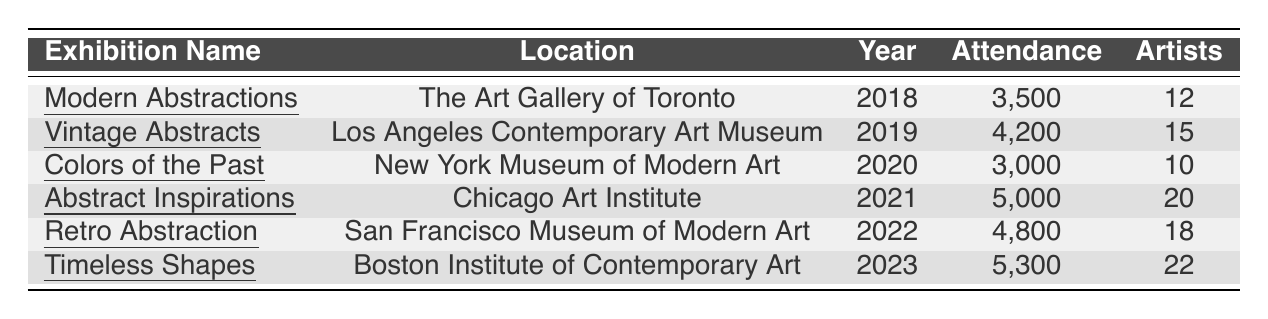What was the attendance for the exhibition "Abstract Inspirations"? The table specifies that the attendance for "Abstract Inspirations" in 2021 was 5,000.
Answer: 5,000 Which exhibition had the highest attendance? By comparing the attendance numbers, it can be seen that "Timeless Shapes" in 2023, with an attendance of 5,300, had the highest attendance.
Answer: 5,300 How many artists participated in "Retro Abstraction"? According to the table, 18 artists participated in the "Retro Abstraction" exhibition in 2022.
Answer: 18 What was the total attendance across all exhibitions from 2018 to 2023? Summing the attendance figures: 3,500 + 4,200 + 3,000 + 5,000 + 4,800 + 5,300 = 25,800.
Answer: 25,800 In which year did "Colors of the Past" take place? The table indicates that "Colors of the Past" was held in 2020.
Answer: 2020 Did the attendance increase from 2019 to 2022? The attendance figures show 4,200 in 2019 and 4,800 in 2022, indicating an increase in attendance between those years.
Answer: Yes What is the average number of artists participating in the exhibitions? To find the average: (12 + 15 + 10 + 20 + 18 + 22) / 6 = 97 / 6 = 16.33.
Answer: 16.33 Is there any exhibition in 2023? The table confirms that "Timeless Shapes" was held in 2023, indicating that there is indeed an exhibition for that year.
Answer: Yes How many total artists participated in the exhibitions for the years 2019 and 2021? The number of artists in 2019 is 15 and in 2021 is 20. Adding these gives 15 + 20 = 35.
Answer: 35 Which exhibition had the least number of participating artists? From the table, "Colors of the Past" in 2020 had the least number of participating artists, with 10.
Answer: 10 Was the attendance for "Vintage Abstracts" higher than that for "Modern Abstractions"? The table shows that "Vintage Abstracts" had 4,200 attendees while "Modern Abstractions" had 3,500, thus confirming that the former had higher attendance.
Answer: Yes 